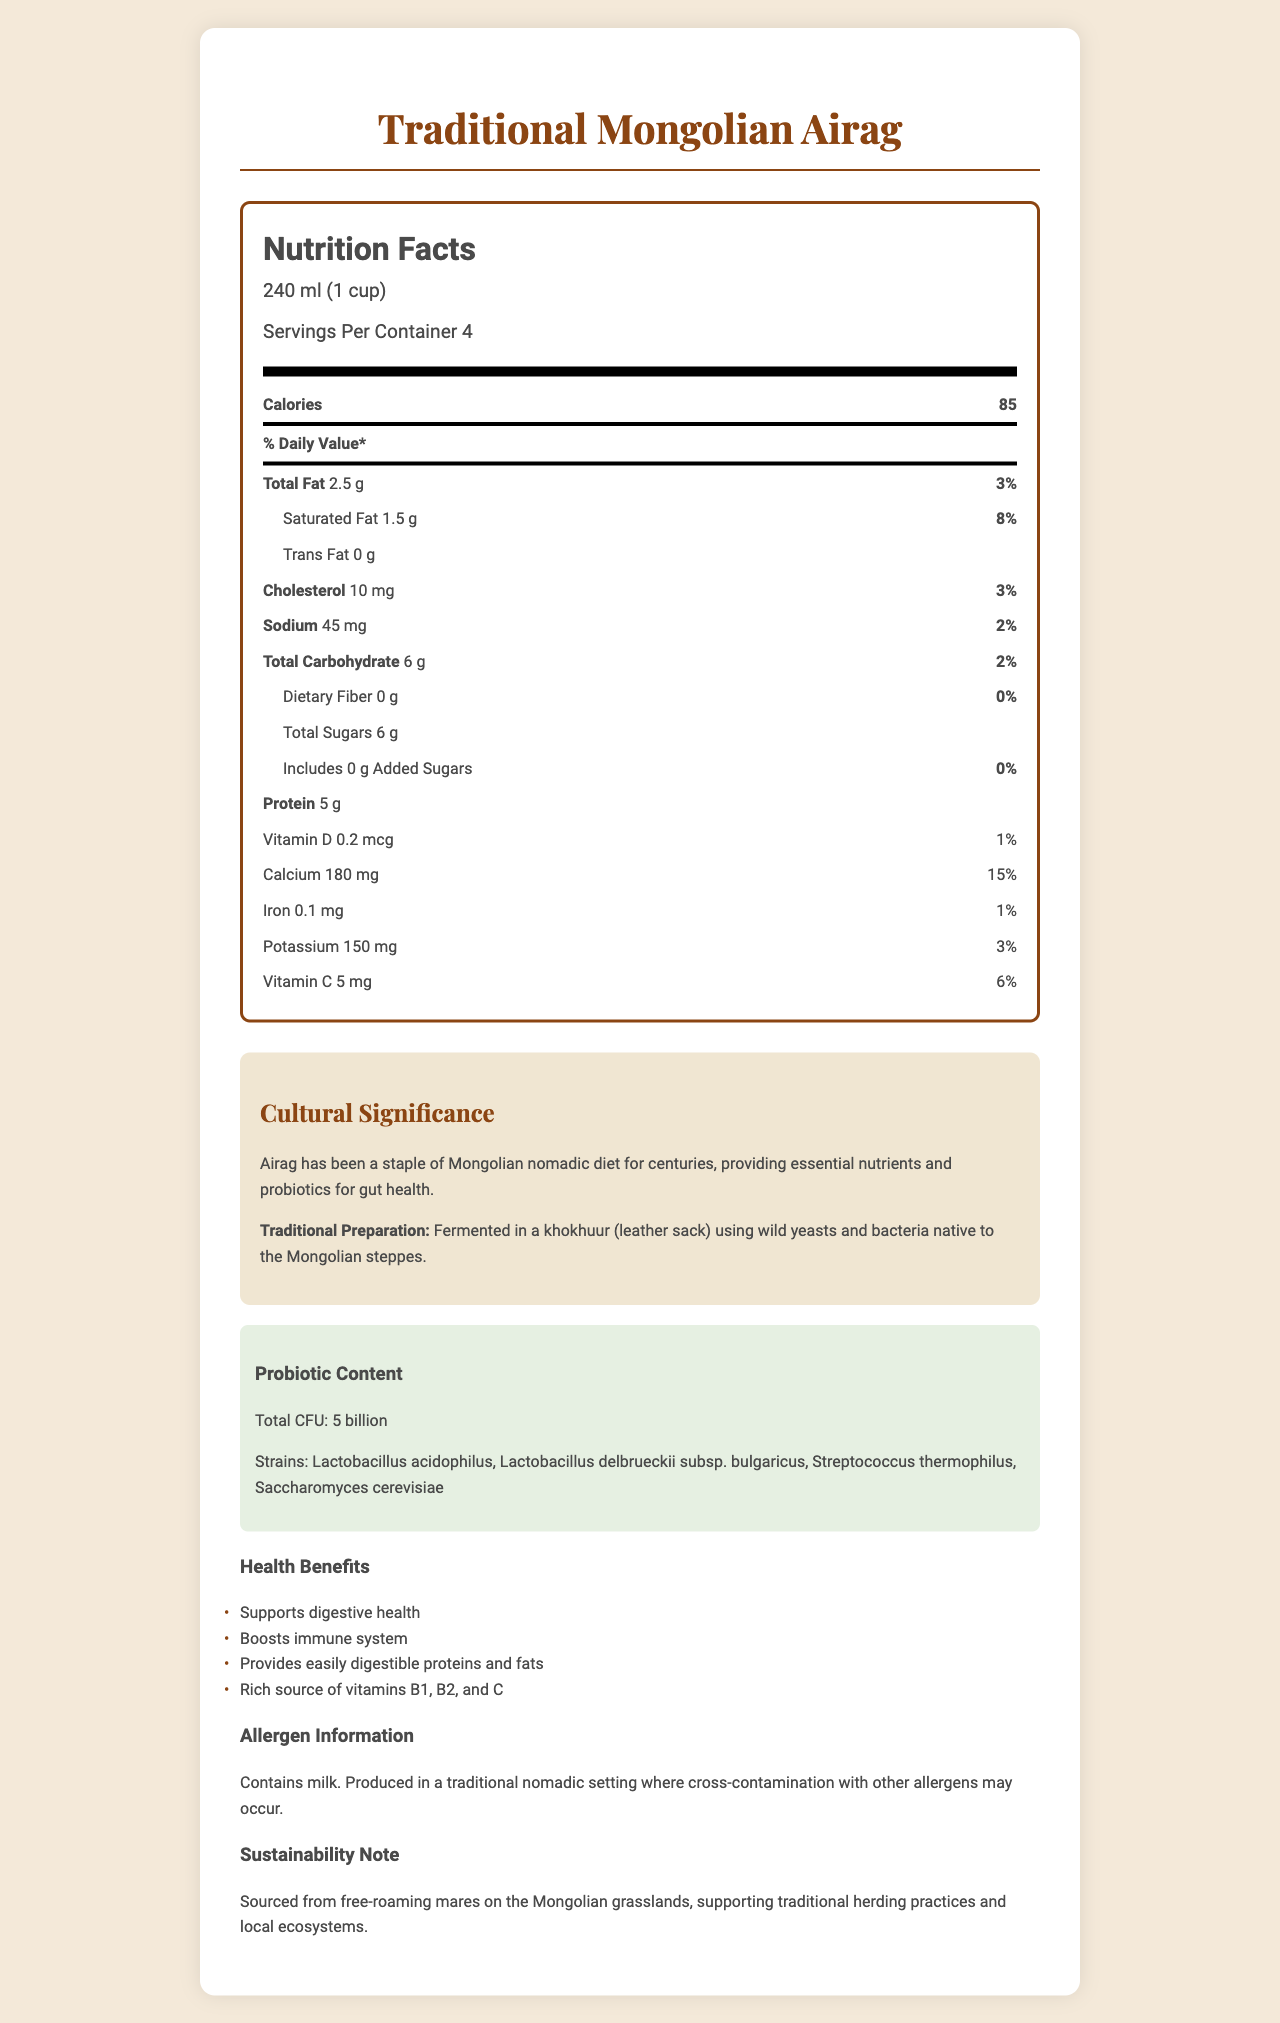What is the serving size of Traditional Mongolian Airag? The serving size is clearly listed as “240 ml (1 cup)” in the initial section of the nutrition label.
Answer: 240 ml (1 cup) How many servings are in one container of Traditional Mongolian Airag? The document states there are "Servings Per Container: 4".
Answer: 4 What are the probiotics strains present in airag? These strains are listed under the "Probiotic Content" section.
Answer: Lactobacillus acidophilus, Lactobacillus delbrueckii subsp. bulgaricus, Streptococcus thermophilus, Saccharomyces cerevisiae How much calcium does one serving of airag provide? The calcium content per serving is listed as “180 mg” in the nutrients section.
Answer: 180 mg What percentage of the daily value of saturated fat is in one serving of airag? The daily value for saturated fat is listed as “8%” in the nutrients section.
Answer: 8% How much total carbohydrate is found in one cup of airag? A. 6 g B. 10 g C. 8 g D. 5 g The nutrients section lists “Total Carbohydrate” as “6 g”.
Answer: A. 6 g Which of the following is not a health benefit of traditional Mongolian airag? i. Supports digestive health ii. Increases muscle mass iii. Boosts immune system iv. Provides easily digestible proteins and fats The health benefits listed do not include increasing muscle mass.
Answer: ii. Increases muscle mass Does airag contain any added sugars? The added sugars amount is listed as “0 g” with a daily value of “0%”.
Answer: No Describe the cultural significance and preparation method of airag as discussed in the document. The cultural significance and traditional preparation methods are detailed in the "Cultural Significance" section.
Answer: Airag has been a staple of the Mongolian nomadic diet for centuries, providing essential nutrients and probiotics for gut health. It is traditionally prepared by fermenting in a khokhuur (leather sack) using wild yeasts and bacteria native to the Mongolian steppes. How much potassium does airag contain per serving? The document lists the potassium content as “150 mg” per serving in the nutrients section.
Answer: 150 mg What type of setting is airag produced in? The document mentions that airag is produced in a traditional nomadic setting, but does not provide specific details about the actual production environment.
Answer: Not enough information What is the total CFU of probiotics in airag? The probiotic content section states the total CFU as “5 billion”.
Answer: 5 billion Does airag provide vitamin C? The document lists the vitamin C content as “5 mg” per serving, which is 6% of the daily value.
Answer: Yes What is one sustainability aspect mentioned about airag? The document includes a note under "Sustainability" about how airag is sourced and its environmental benefits.
Answer: Sourced from free-roaming mares on the Mongolian grasslands, supporting traditional herding practices and local ecosystems. What food allergen is mentioned in the document for airag? The allergen information clearly states that airag contains milk.
Answer: Milk 